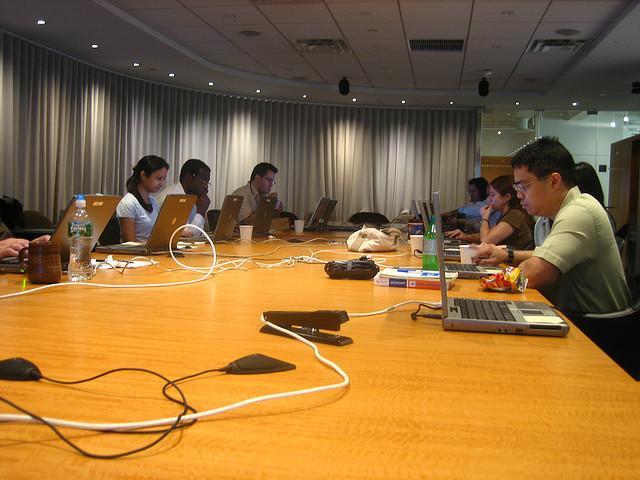Where are the people in?

Choices:
A) cafeteria
B) theater
C) library
D) conference room conference room 